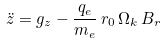Convert formula to latex. <formula><loc_0><loc_0><loc_500><loc_500>\ddot { z } = g _ { z } - \frac { q _ { e } } { m _ { e } } \, r _ { 0 } \, \Omega _ { k } \, B _ { r }</formula> 